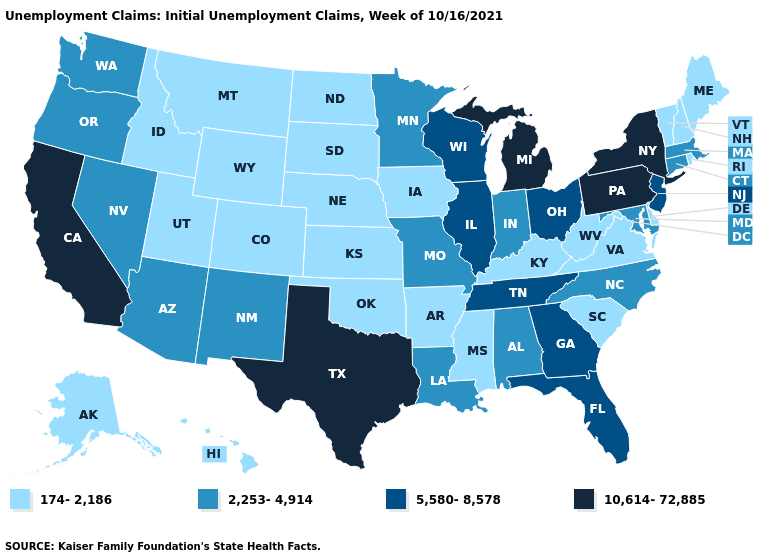What is the value of Maryland?
Give a very brief answer. 2,253-4,914. What is the lowest value in the USA?
Keep it brief. 174-2,186. Among the states that border Maine , which have the highest value?
Write a very short answer. New Hampshire. What is the value of Missouri?
Be succinct. 2,253-4,914. Name the states that have a value in the range 2,253-4,914?
Concise answer only. Alabama, Arizona, Connecticut, Indiana, Louisiana, Maryland, Massachusetts, Minnesota, Missouri, Nevada, New Mexico, North Carolina, Oregon, Washington. Name the states that have a value in the range 2,253-4,914?
Write a very short answer. Alabama, Arizona, Connecticut, Indiana, Louisiana, Maryland, Massachusetts, Minnesota, Missouri, Nevada, New Mexico, North Carolina, Oregon, Washington. Does Illinois have the highest value in the MidWest?
Be succinct. No. What is the value of Georgia?
Keep it brief. 5,580-8,578. What is the lowest value in the West?
Short answer required. 174-2,186. Does the map have missing data?
Be succinct. No. Among the states that border Illinois , does Kentucky have the lowest value?
Keep it brief. Yes. Does New Hampshire have the lowest value in the USA?
Quick response, please. Yes. Name the states that have a value in the range 174-2,186?
Concise answer only. Alaska, Arkansas, Colorado, Delaware, Hawaii, Idaho, Iowa, Kansas, Kentucky, Maine, Mississippi, Montana, Nebraska, New Hampshire, North Dakota, Oklahoma, Rhode Island, South Carolina, South Dakota, Utah, Vermont, Virginia, West Virginia, Wyoming. Which states have the lowest value in the USA?
Write a very short answer. Alaska, Arkansas, Colorado, Delaware, Hawaii, Idaho, Iowa, Kansas, Kentucky, Maine, Mississippi, Montana, Nebraska, New Hampshire, North Dakota, Oklahoma, Rhode Island, South Carolina, South Dakota, Utah, Vermont, Virginia, West Virginia, Wyoming. 